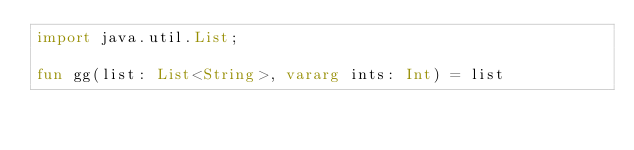Convert code to text. <code><loc_0><loc_0><loc_500><loc_500><_Kotlin_>import java.util.List;

fun gg(list: List<String>, vararg ints: Int) = list
</code> 